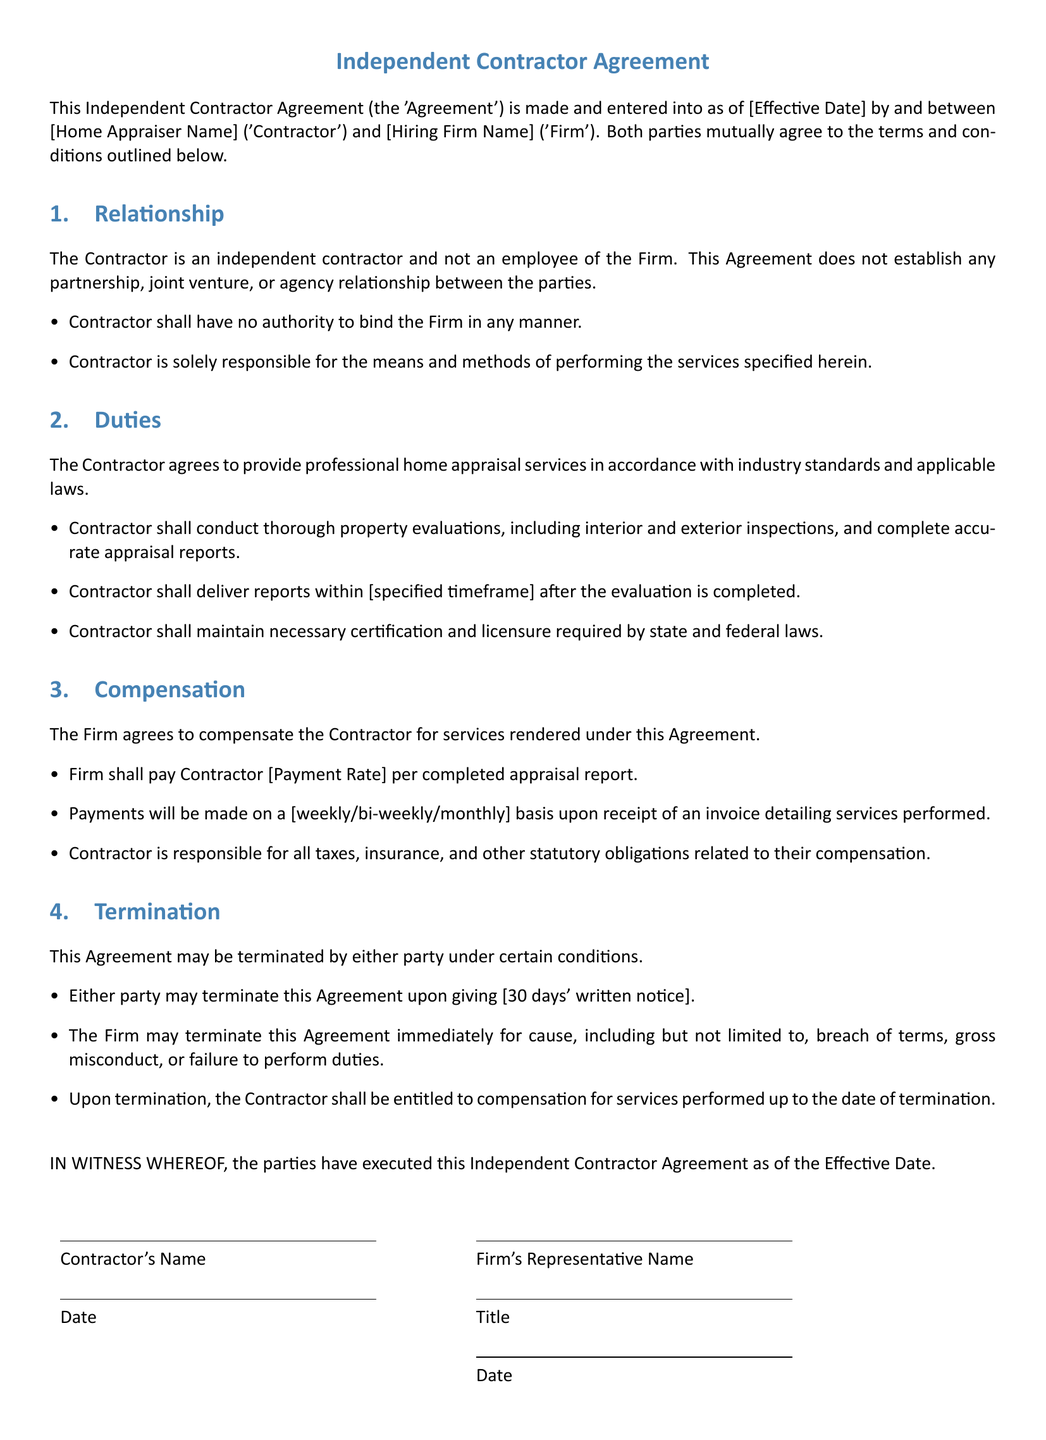What is the title of the document? The title is prominently stated at the beginning of the document, indicating its purpose.
Answer: Independent Contractor Agreement Who are the parties involved in this agreement? The document specifies the names of the parties in the introductory section.
Answer: Contractor and Firm What is the payment rate for the contractor? The payment rate for services is specified in the compensation section.
Answer: [Payment Rate] What is the notice period for termination? The termination section outlines the required notice period before termination.
Answer: 30 days' written notice What services does the contractor agree to provide? The duties section describes the professional services the contractor must deliver.
Answer: Professional home appraisal services Under what circumstances can the Firm terminate the agreement immediately? The termination section lists specific reasons for immediate termination by the Firm.
Answer: Breach of terms, gross misconduct, or failure to perform duties Who is responsible for taxes related to contractor's compensation? The compensation section specifies the accountability regarding taxes.
Answer: Contractor What must the contractor maintain according to the duties? The duties section emphasizes the importance of certain qualifications for the contractor.
Answer: Necessary certification and licensure When are payments made to the contractor? The compensation section mentions the frequency of payments following services performed.
Answer: [weekly/bi-weekly/monthly] basis 